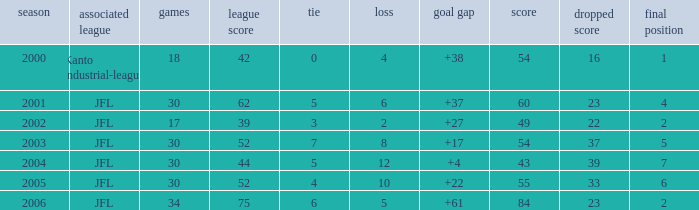Tell me the highest point with lost point being 33 and league point less than 52 None. 